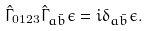Convert formula to latex. <formula><loc_0><loc_0><loc_500><loc_500>\hat { \Gamma } _ { 0 1 2 3 } \hat { \Gamma } _ { a \bar { b } } \epsilon = i \delta _ { a \bar { b } } \epsilon .</formula> 